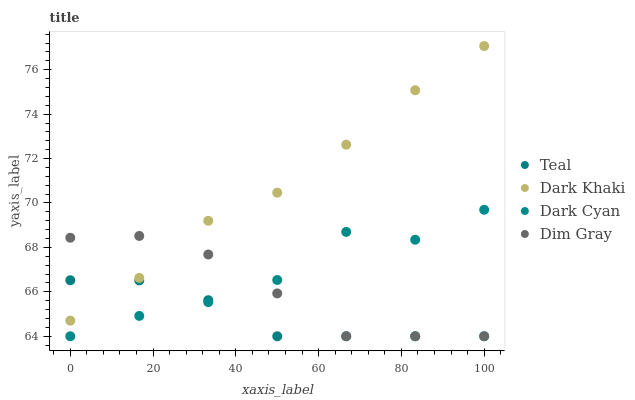Does Teal have the minimum area under the curve?
Answer yes or no. Yes. Does Dark Khaki have the maximum area under the curve?
Answer yes or no. Yes. Does Dark Cyan have the minimum area under the curve?
Answer yes or no. No. Does Dark Cyan have the maximum area under the curve?
Answer yes or no. No. Is Teal the smoothest?
Answer yes or no. Yes. Is Dark Cyan the roughest?
Answer yes or no. Yes. Is Dim Gray the smoothest?
Answer yes or no. No. Is Dim Gray the roughest?
Answer yes or no. No. Does Dark Cyan have the lowest value?
Answer yes or no. Yes. Does Dark Khaki have the highest value?
Answer yes or no. Yes. Does Dark Cyan have the highest value?
Answer yes or no. No. Is Dark Cyan less than Dark Khaki?
Answer yes or no. Yes. Is Dark Khaki greater than Dark Cyan?
Answer yes or no. Yes. Does Dark Cyan intersect Dim Gray?
Answer yes or no. Yes. Is Dark Cyan less than Dim Gray?
Answer yes or no. No. Is Dark Cyan greater than Dim Gray?
Answer yes or no. No. Does Dark Cyan intersect Dark Khaki?
Answer yes or no. No. 